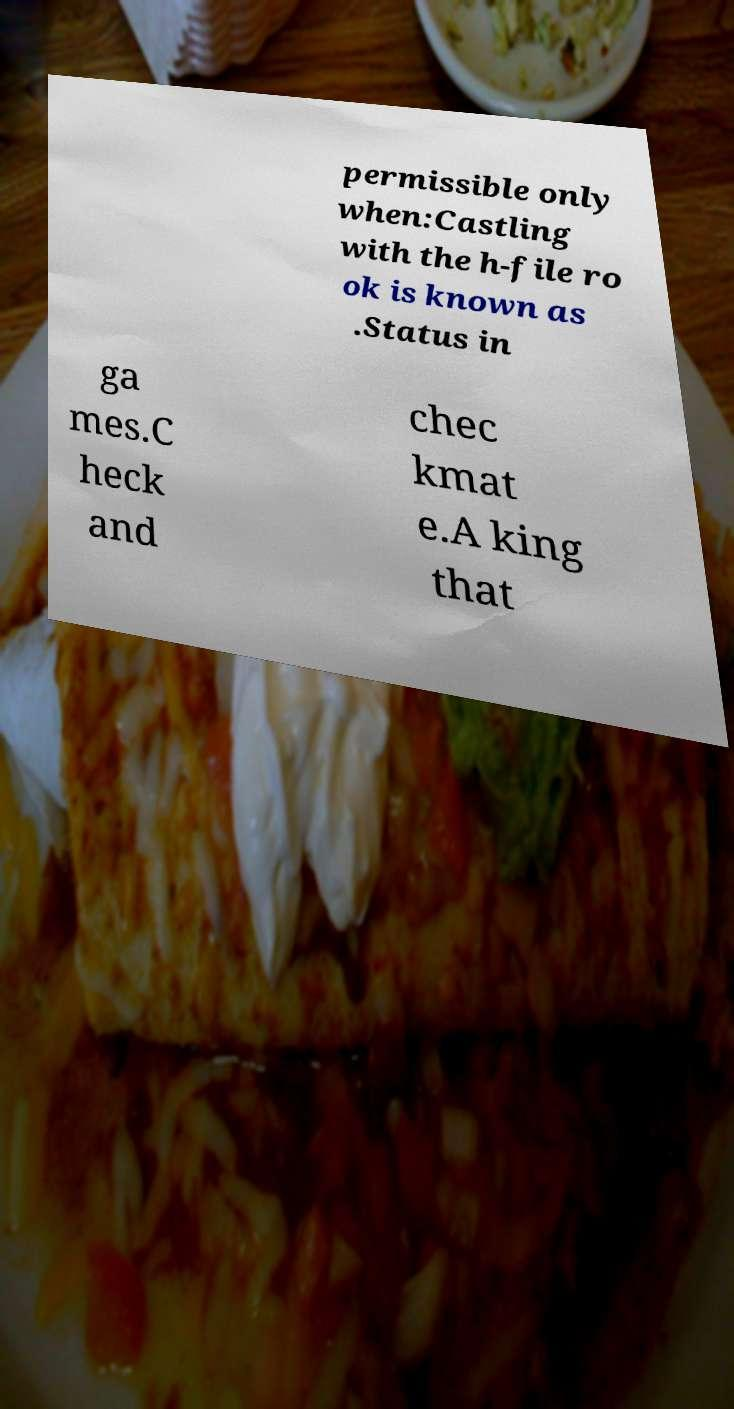Could you assist in decoding the text presented in this image and type it out clearly? permissible only when:Castling with the h-file ro ok is known as .Status in ga mes.C heck and chec kmat e.A king that 